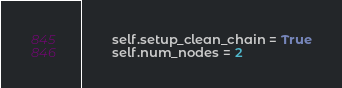<code> <loc_0><loc_0><loc_500><loc_500><_Python_>        self.setup_clean_chain = True
        self.num_nodes = 2</code> 